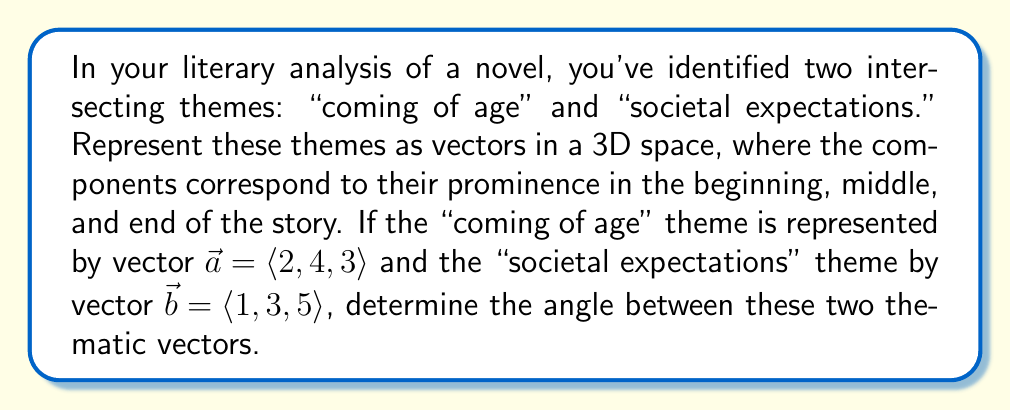What is the answer to this math problem? To find the angle between two vectors, we can use the dot product formula:

$$\cos \theta = \frac{\vec{a} \cdot \vec{b}}{|\vec{a}| |\vec{b}|}$$

where $\theta$ is the angle between the vectors, $\vec{a} \cdot \vec{b}$ is the dot product, and $|\vec{a}|$ and $|\vec{b}|$ are the magnitudes of the vectors.

Step 1: Calculate the dot product $\vec{a} \cdot \vec{b}$
$$\vec{a} \cdot \vec{b} = (2)(1) + (4)(3) + (3)(5) = 2 + 12 + 15 = 29$$

Step 2: Calculate the magnitudes of $\vec{a}$ and $\vec{b}$
$$|\vec{a}| = \sqrt{2^2 + 4^2 + 3^2} = \sqrt{4 + 16 + 9} = \sqrt{29}$$
$$|\vec{b}| = \sqrt{1^2 + 3^2 + 5^2} = \sqrt{1 + 9 + 25} = \sqrt{35}$$

Step 3: Substitute into the dot product formula
$$\cos \theta = \frac{29}{\sqrt{29} \sqrt{35}}$$

Step 4: Simplify
$$\cos \theta = \frac{29}{\sqrt{1015}}$$

Step 5: Take the inverse cosine (arccos) of both sides
$$\theta = \arccos\left(\frac{29}{\sqrt{1015}}\right)$$

Step 6: Calculate the result (rounded to two decimal places)
$$\theta \approx 0.39 \text{ radians} \approx 22.35°$$
Answer: The angle between the two thematic vectors is approximately 22.35°. 